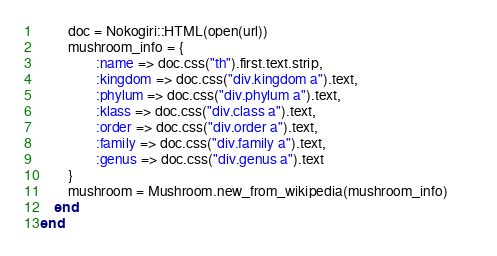<code> <loc_0><loc_0><loc_500><loc_500><_Ruby_>        doc = Nokogiri::HTML(open(url))
        mushroom_info = {
                :name => doc.css("th").first.text.strip,
                :kingdom => doc.css("div.kingdom a").text,
                :phylum => doc.css("div.phylum a").text,
                :klass => doc.css("div.class a").text,
                :order => doc.css("div.order a").text,
                :family => doc.css("div.family a").text,
                :genus => doc.css("div.genus a").text
        }
        mushroom = Mushroom.new_from_wikipedia(mushroom_info)       
    end    
end

</code> 